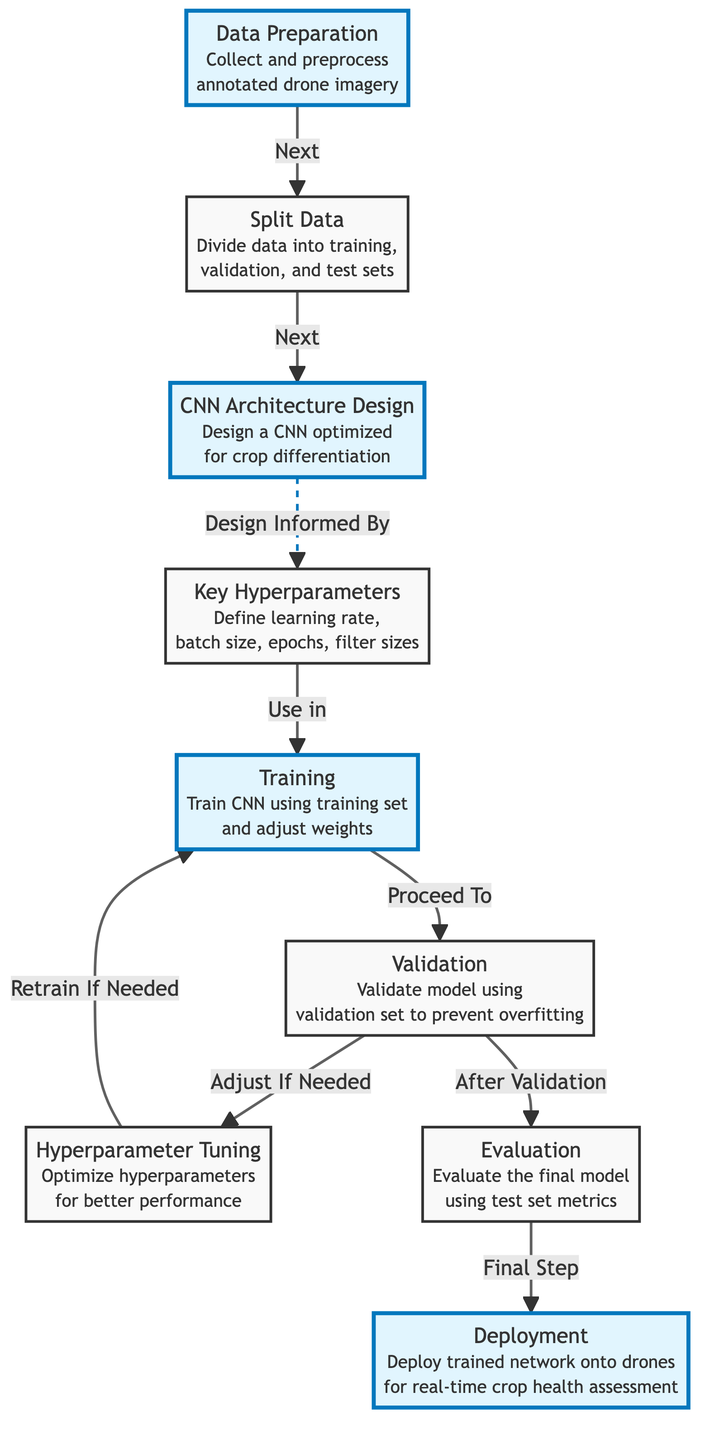What is the first step in the process? The diagram starts with the "Data Preparation" node, which is the first step to collect and preprocess annotated drone imagery.
Answer: Data Preparation How many main steps are highlighted in the diagram? The highlighted main steps are Data Preparation, CNN Architecture Design, Training, Evaluation, and Deployment. There are five highlighted steps in total.
Answer: Five What do you do after the Validation step? After the Validation step, the next step indicated in the diagram is Evaluation.
Answer: Evaluation What is the relationship between architecture design and hyperparameters? The diagram shows a dashed line indicating that the CNN Architecture Design is informed by the Hyperparameters.
Answer: Design Informed By What happens if validation indicates the need for adjustments? If validation indicates the need for adjustments, the process goes to Hyperparameter Tuning to optimize hyperparameters for better performance.
Answer: Hyperparameter Tuning How many nodes are involved in the training and validation stages combined? The training stage consists of one node (Training) and the validation stage consists of one node (Validation), so there are two nodes combined.
Answer: Two What is the last step before the deployment of the model? The last step before deployment, as shown in the diagram, is Evaluation, where the final model is evaluated using test set metrics.
Answer: Evaluation Which step directly precedes Hyperparameter Tuning? The step that directly precedes Hyperparameter Tuning is Validation which checks the model to prevent overfitting.
Answer: Validation What is the role of Hyperparameters in this process? Hyperparameters define critical aspects of the training process like learning rate, batch size, epochs, and filter sizes, as indicated in the diagram.
Answer: Define learning rate, batch size, epochs, filter sizes 